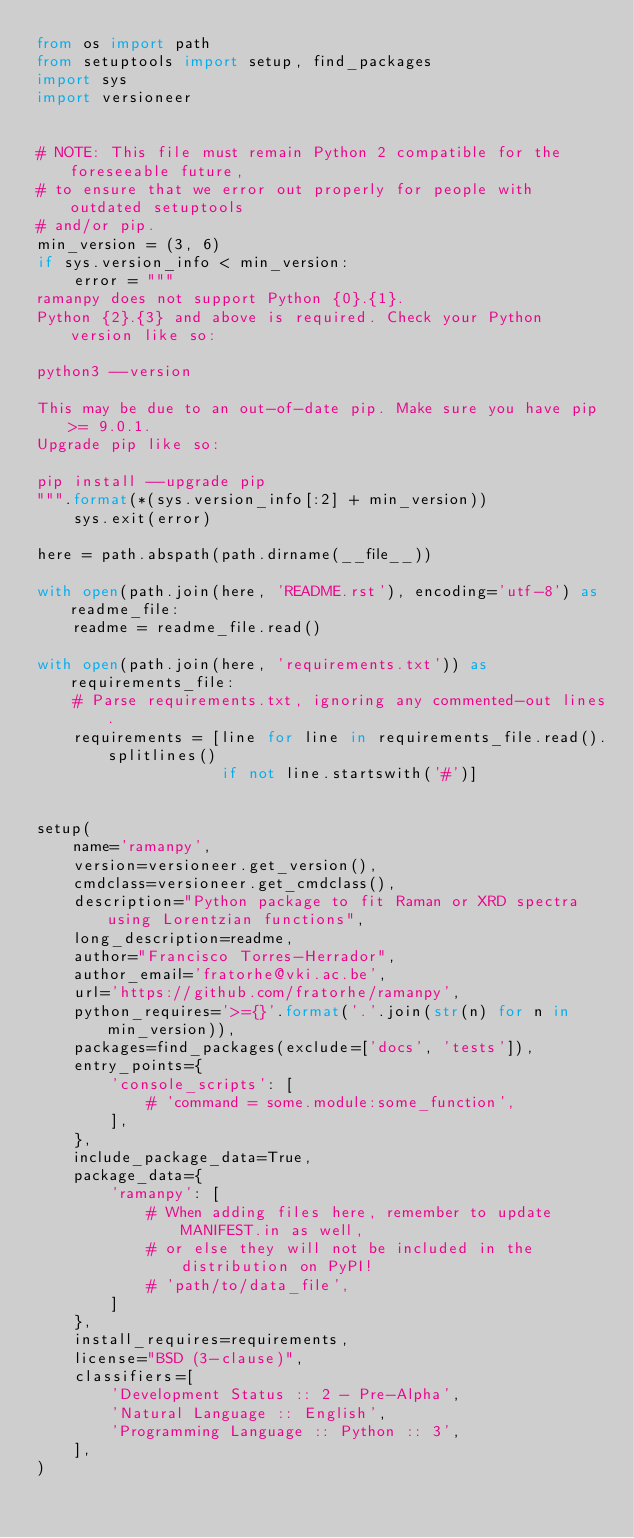Convert code to text. <code><loc_0><loc_0><loc_500><loc_500><_Python_>from os import path
from setuptools import setup, find_packages
import sys
import versioneer


# NOTE: This file must remain Python 2 compatible for the foreseeable future,
# to ensure that we error out properly for people with outdated setuptools
# and/or pip.
min_version = (3, 6)
if sys.version_info < min_version:
    error = """
ramanpy does not support Python {0}.{1}.
Python {2}.{3} and above is required. Check your Python version like so:

python3 --version

This may be due to an out-of-date pip. Make sure you have pip >= 9.0.1.
Upgrade pip like so:

pip install --upgrade pip
""".format(*(sys.version_info[:2] + min_version))
    sys.exit(error)

here = path.abspath(path.dirname(__file__))

with open(path.join(here, 'README.rst'), encoding='utf-8') as readme_file:
    readme = readme_file.read()

with open(path.join(here, 'requirements.txt')) as requirements_file:
    # Parse requirements.txt, ignoring any commented-out lines.
    requirements = [line for line in requirements_file.read().splitlines()
                    if not line.startswith('#')]


setup(
    name='ramanpy',
    version=versioneer.get_version(),
    cmdclass=versioneer.get_cmdclass(),
    description="Python package to fit Raman or XRD spectra using Lorentzian functions",
    long_description=readme,
    author="Francisco Torres-Herrador",
    author_email='fratorhe@vki.ac.be',
    url='https://github.com/fratorhe/ramanpy',
    python_requires='>={}'.format('.'.join(str(n) for n in min_version)),
    packages=find_packages(exclude=['docs', 'tests']),
    entry_points={
        'console_scripts': [
            # 'command = some.module:some_function',
        ],
    },
    include_package_data=True,
    package_data={
        'ramanpy': [
            # When adding files here, remember to update MANIFEST.in as well,
            # or else they will not be included in the distribution on PyPI!
            # 'path/to/data_file',
        ]
    },
    install_requires=requirements,
    license="BSD (3-clause)",
    classifiers=[
        'Development Status :: 2 - Pre-Alpha',
        'Natural Language :: English',
        'Programming Language :: Python :: 3',
    ],
)
</code> 